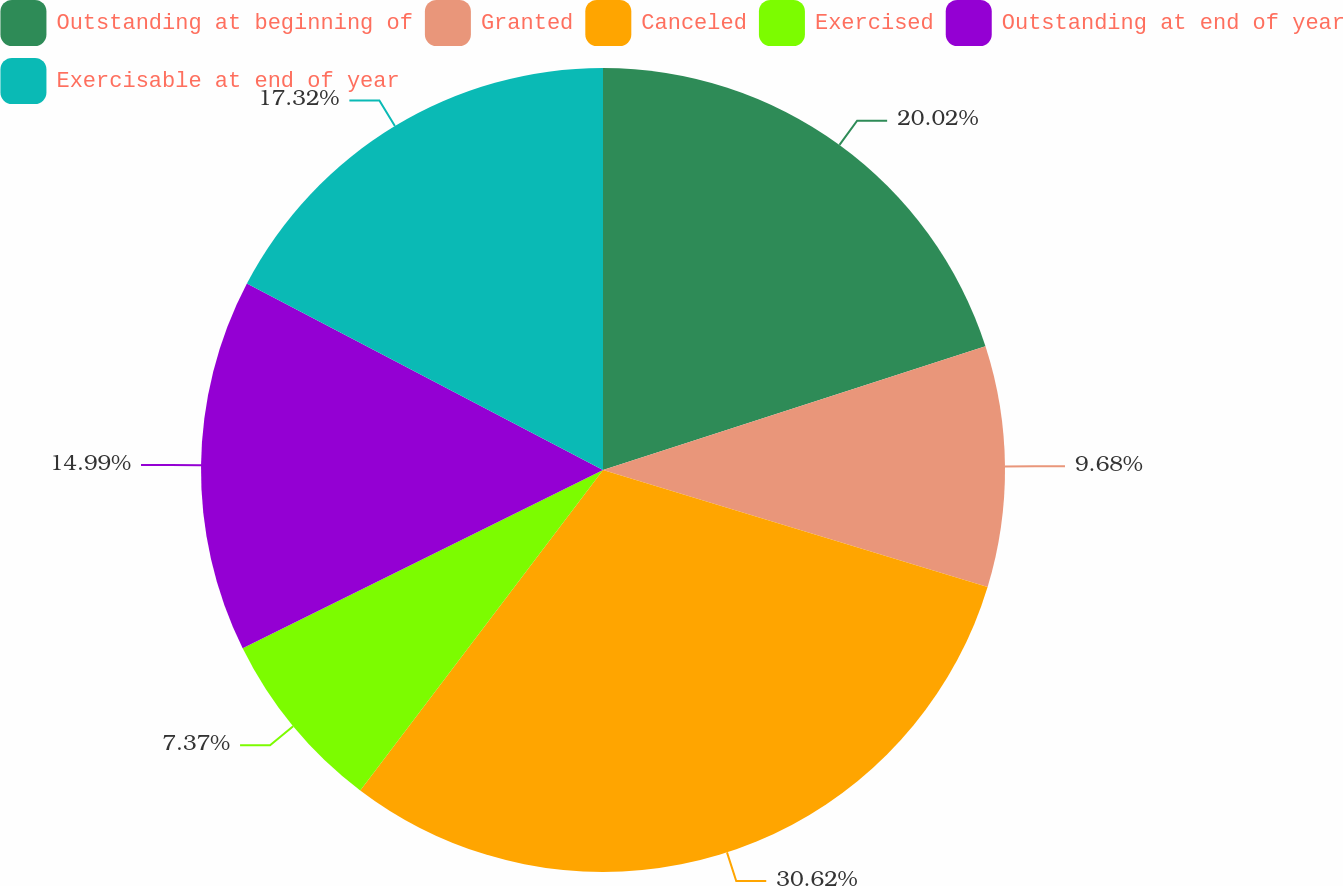Convert chart to OTSL. <chart><loc_0><loc_0><loc_500><loc_500><pie_chart><fcel>Outstanding at beginning of<fcel>Granted<fcel>Canceled<fcel>Exercised<fcel>Outstanding at end of year<fcel>Exercisable at end of year<nl><fcel>20.02%<fcel>9.68%<fcel>30.62%<fcel>7.37%<fcel>14.99%<fcel>17.32%<nl></chart> 